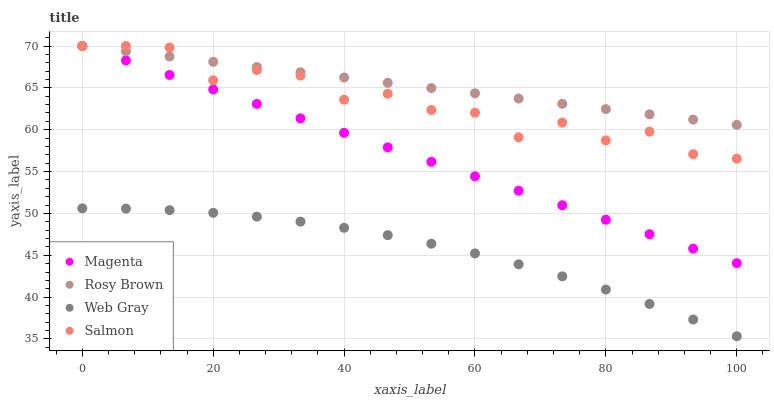Does Web Gray have the minimum area under the curve?
Answer yes or no. Yes. Does Rosy Brown have the maximum area under the curve?
Answer yes or no. Yes. Does Magenta have the minimum area under the curve?
Answer yes or no. No. Does Magenta have the maximum area under the curve?
Answer yes or no. No. Is Magenta the smoothest?
Answer yes or no. Yes. Is Salmon the roughest?
Answer yes or no. Yes. Is Rosy Brown the smoothest?
Answer yes or no. No. Is Rosy Brown the roughest?
Answer yes or no. No. Does Web Gray have the lowest value?
Answer yes or no. Yes. Does Magenta have the lowest value?
Answer yes or no. No. Does Rosy Brown have the highest value?
Answer yes or no. Yes. Does Web Gray have the highest value?
Answer yes or no. No. Is Web Gray less than Salmon?
Answer yes or no. Yes. Is Magenta greater than Web Gray?
Answer yes or no. Yes. Does Magenta intersect Rosy Brown?
Answer yes or no. Yes. Is Magenta less than Rosy Brown?
Answer yes or no. No. Is Magenta greater than Rosy Brown?
Answer yes or no. No. Does Web Gray intersect Salmon?
Answer yes or no. No. 